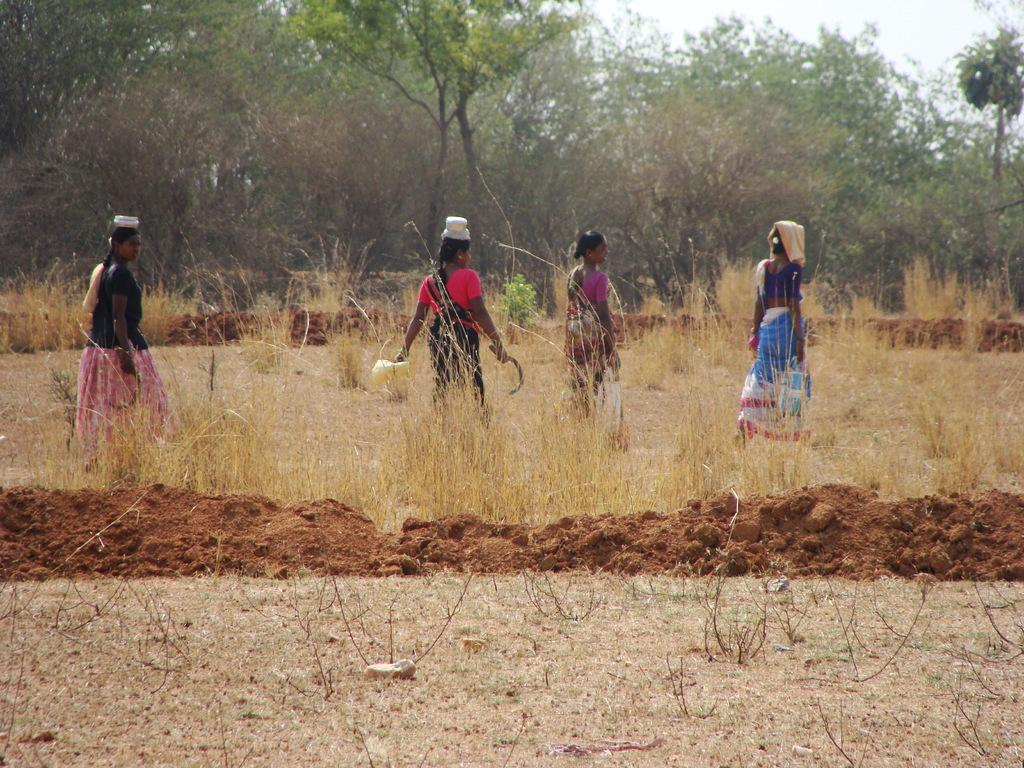What is the main subject of the image? There is a farmer woman standing in the crop. What can be seen in the background of the image? There are plants and trees in the background of the image. What is visible in the sky in the image? The sky is visible in the background of the image. How many needles are being used by the farmer woman in the image? There are no needles present in the image; the farmer woman is standing in a crop. 